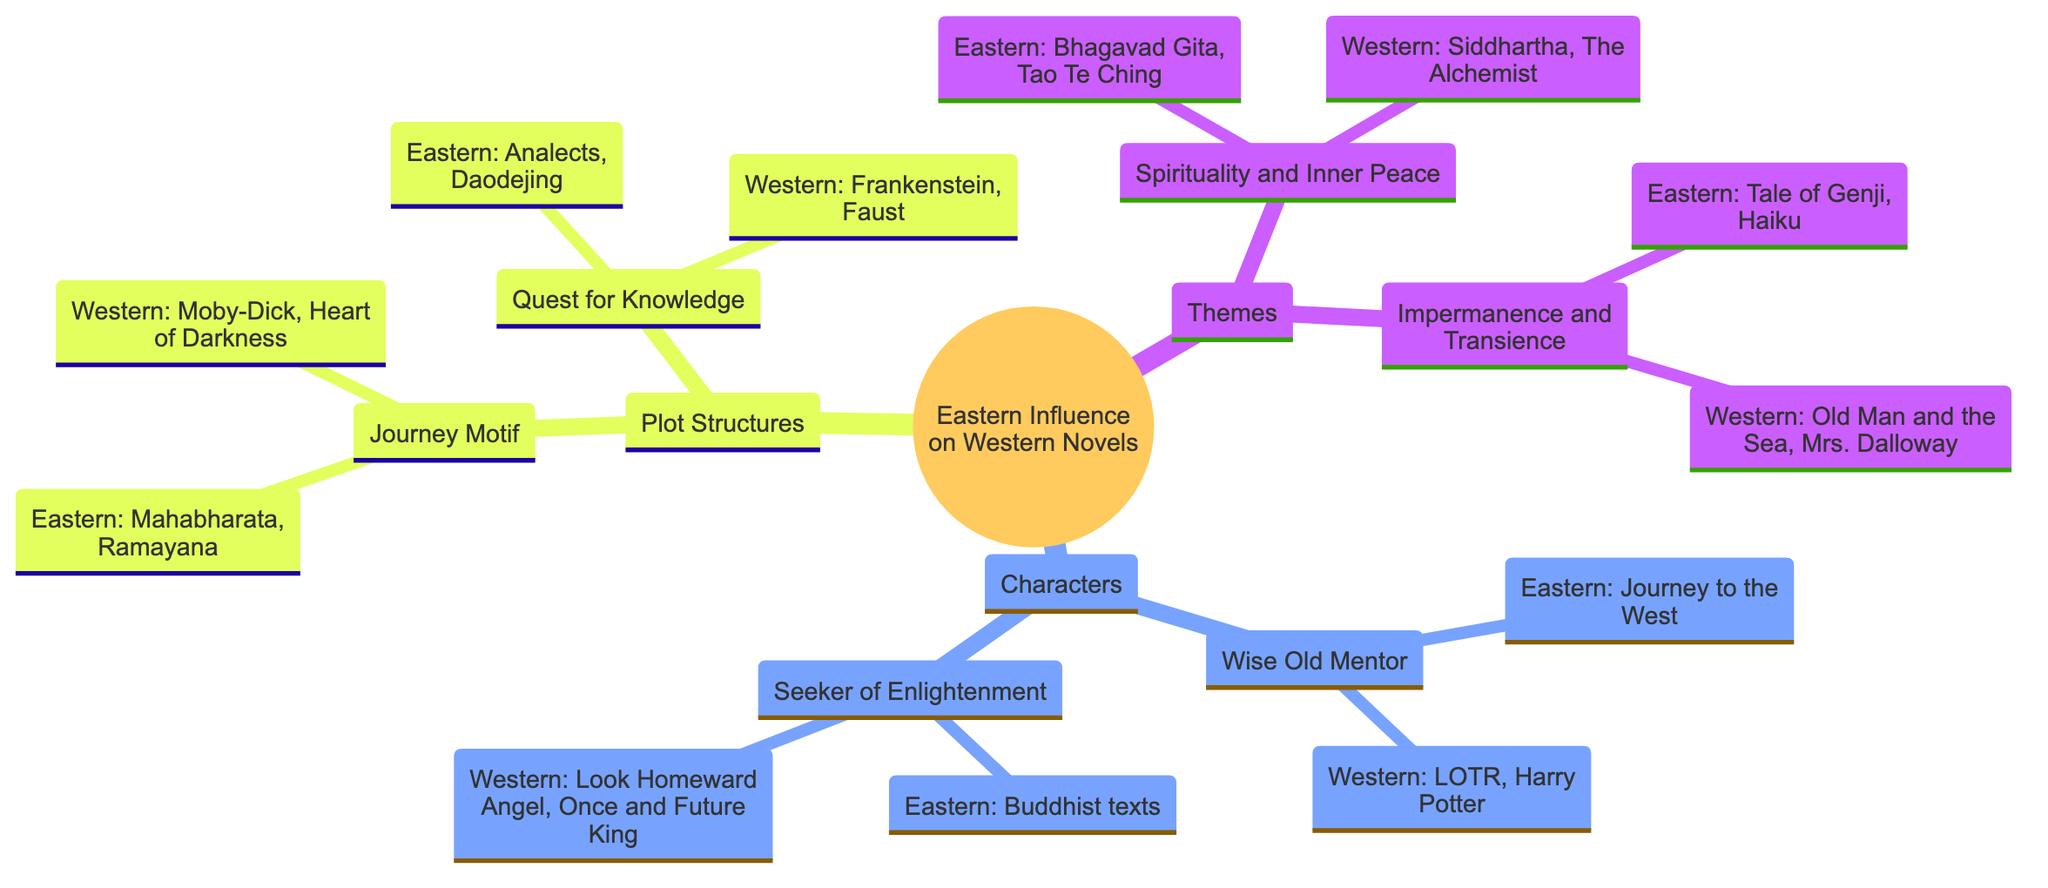What are the two main categories of influence shown in the diagram? The diagram's root node branches into three main categories: "Themes," "Characters," and "Plot Structures." These categories organize how Eastern literature influences Western novels.
Answer: Themes, Characters, Plot Structures Which Western novel exemplifies the theme of "Spirituality and Inner Peace"? Under the "Spirituality and Inner Peace" theme, the Western novels listed include Herman Hesse's "Siddhartha" and Paulo Coelho's "The Alchemist." Either can be considered as an example, but "Siddhartha" stands out more prominently.
Answer: Siddhartha How many Eastern influences are listed under the "Characters" category? In the "Characters" category, there are two main influences: "Wise Old Mentor" and "Seeker of Enlightenment," each with specific Eastern examples provided. Thus, there are two Eastern influences mentioned.
Answer: 2 Which character from an Eastern influence is highlighted? The "Wise Old Mentor" influence refers to Xuanzang from the Chinese classic "Journey to the West." This character is specifically noted for representing this archetype in the Eastern context.
Answer: Xuanzang What is a common plot structure observed in both Eastern and Western literature according to the diagram? Both the "Journey Motif" and "Quest for Knowledge" plot structures are illustrated in the diagram with examples from Eastern and Western sources, highlighting the shared narrative forms.
Answer: Journey Motif, Quest for Knowledge In which Eastern text is the theme of "Impermanence and Transience" expressed? The theme "Impermanence and Transience" is reflected in Japanese literature, especially through the example given of "The Tale of Genji" and haiku poetry, which embody this concept.
Answer: Tale of Genji Which two characters signify the "Seeker of Enlightenment" in Western novels? The "Seeker of Enlightenment" character type in Western novels is illustrated with examples of Eugene Gant from Thomas Wolfe's "Look Homeward, Angel" and Arthur from T.H. White's "The Once and Future King." Both these protagonists represent this archetype.
Answer: Eugene Gant, Arthur How many different themes are depicted in the diagram? The diagram shows two distinct themes: "Spirituality and Inner Peace" and "Impermanence and Transience," making a total of two themes highlighted in the analysis.
Answer: 2 Which Eastern piece illustrates the "Quest for Knowledge"? The Eastern influence under the "Quest for Knowledge" is signified by the "Analects" by Confucius and "Daodejing" by Laozi, both of which are recognized for representing this theme in Eastern literature.
Answer: Analects, Daodejing 